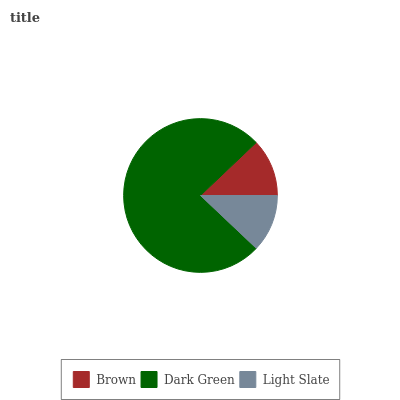Is Light Slate the minimum?
Answer yes or no. Yes. Is Dark Green the maximum?
Answer yes or no. Yes. Is Dark Green the minimum?
Answer yes or no. No. Is Light Slate the maximum?
Answer yes or no. No. Is Dark Green greater than Light Slate?
Answer yes or no. Yes. Is Light Slate less than Dark Green?
Answer yes or no. Yes. Is Light Slate greater than Dark Green?
Answer yes or no. No. Is Dark Green less than Light Slate?
Answer yes or no. No. Is Brown the high median?
Answer yes or no. Yes. Is Brown the low median?
Answer yes or no. Yes. Is Light Slate the high median?
Answer yes or no. No. Is Light Slate the low median?
Answer yes or no. No. 